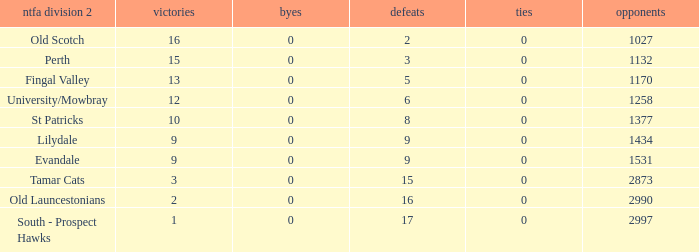What is the lowest number of draws of the team with 9 wins and less than 0 byes? None. 